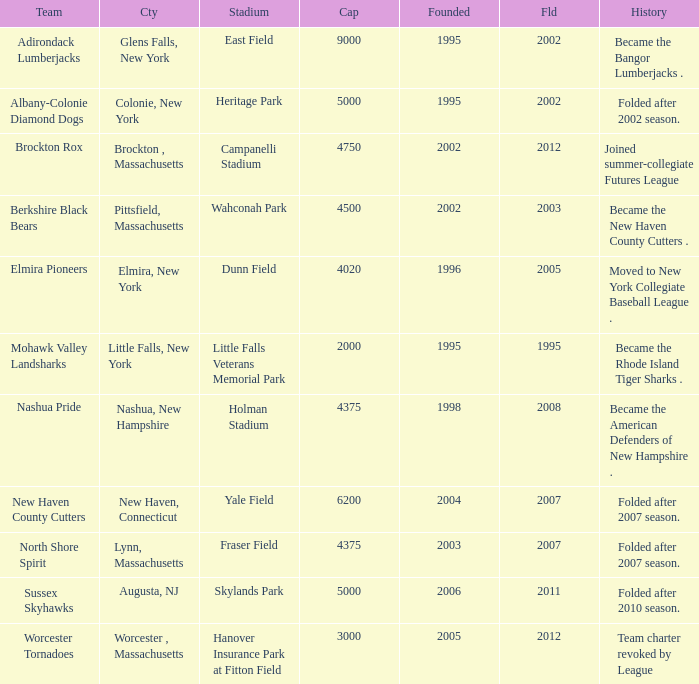What is the maximum founded year of the Worcester Tornadoes? 2005.0. 